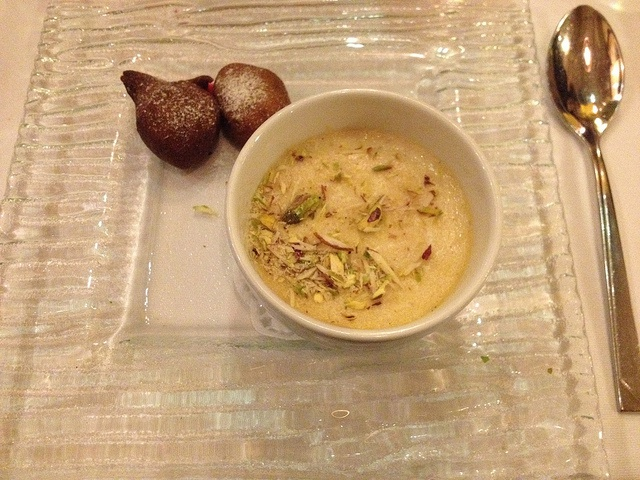Describe the objects in this image and their specific colors. I can see dining table in tan and gray tones, bowl in tan, olive, and orange tones, and spoon in tan, brown, maroon, and gray tones in this image. 